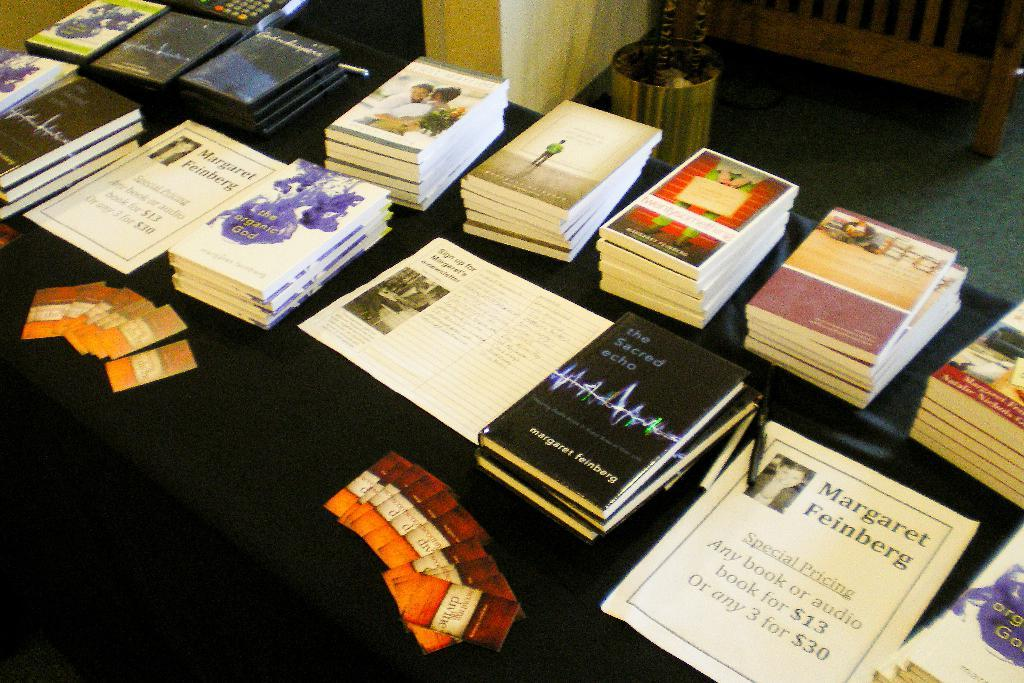Provide a one-sentence caption for the provided image. A table with many books sitting on it along with a Margaret Feinberg poster. 